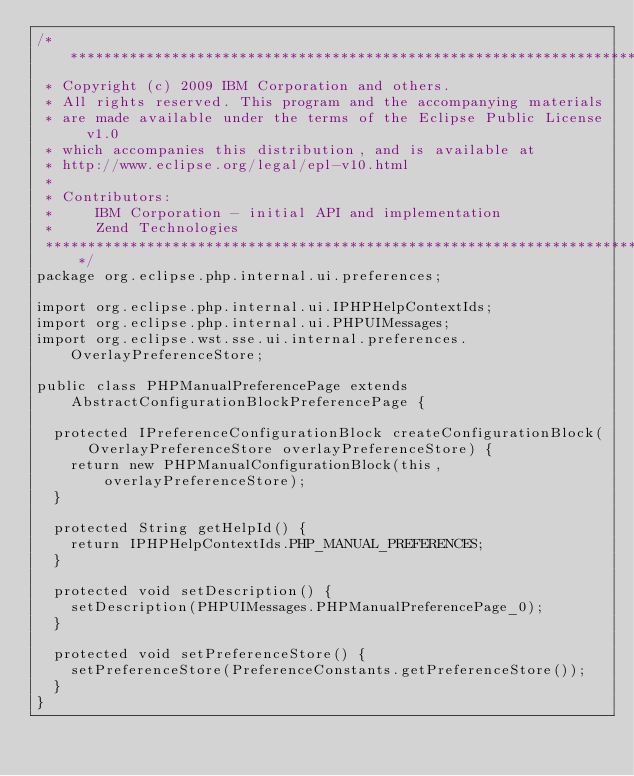<code> <loc_0><loc_0><loc_500><loc_500><_Java_>/*******************************************************************************
 * Copyright (c) 2009 IBM Corporation and others.
 * All rights reserved. This program and the accompanying materials
 * are made available under the terms of the Eclipse Public License v1.0
 * which accompanies this distribution, and is available at
 * http://www.eclipse.org/legal/epl-v10.html
 * 
 * Contributors:
 *     IBM Corporation - initial API and implementation
 *     Zend Technologies
 *******************************************************************************/
package org.eclipse.php.internal.ui.preferences;

import org.eclipse.php.internal.ui.IPHPHelpContextIds;
import org.eclipse.php.internal.ui.PHPUIMessages;
import org.eclipse.wst.sse.ui.internal.preferences.OverlayPreferenceStore;

public class PHPManualPreferencePage extends
		AbstractConfigurationBlockPreferencePage {

	protected IPreferenceConfigurationBlock createConfigurationBlock(
			OverlayPreferenceStore overlayPreferenceStore) {
		return new PHPManualConfigurationBlock(this, overlayPreferenceStore);
	}

	protected String getHelpId() {
		return IPHPHelpContextIds.PHP_MANUAL_PREFERENCES;
	}

	protected void setDescription() {
		setDescription(PHPUIMessages.PHPManualPreferencePage_0); 
	}

	protected void setPreferenceStore() {
		setPreferenceStore(PreferenceConstants.getPreferenceStore());
	}
}
</code> 